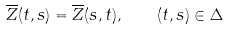<formula> <loc_0><loc_0><loc_500><loc_500>\overline { Z } ( t , s ) = \overline { Z } ( s , t ) , \quad ( t , s ) \in \Delta</formula> 